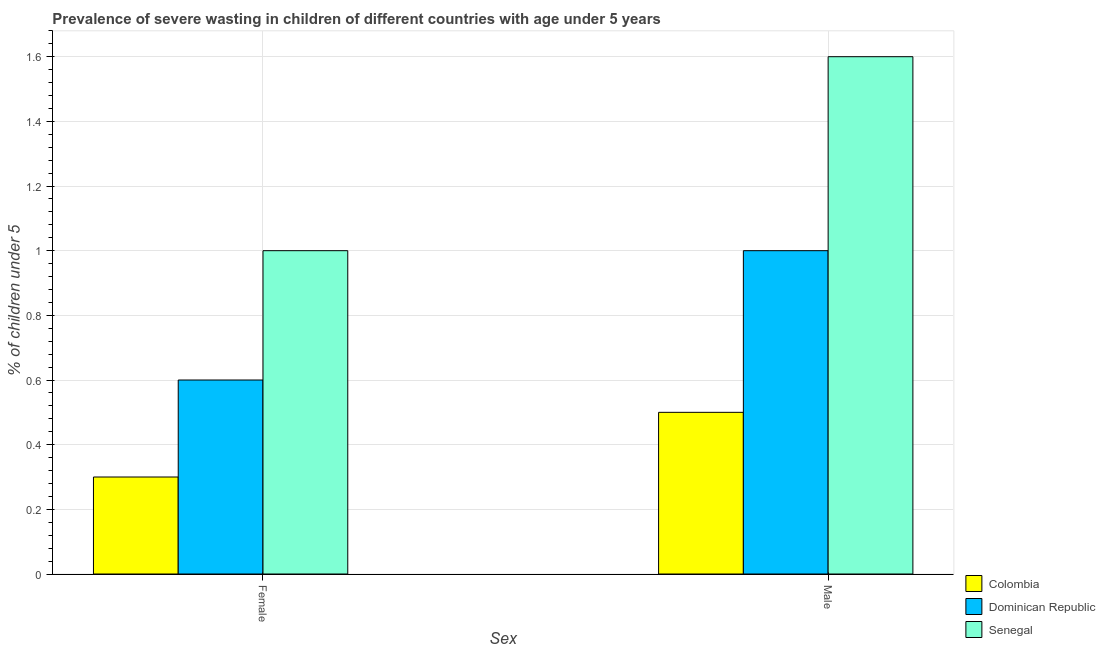How many different coloured bars are there?
Your answer should be compact. 3. Are the number of bars per tick equal to the number of legend labels?
Offer a very short reply. Yes. Are the number of bars on each tick of the X-axis equal?
Offer a terse response. Yes. What is the label of the 2nd group of bars from the left?
Your answer should be compact. Male. Across all countries, what is the maximum percentage of undernourished male children?
Ensure brevity in your answer.  1.6. In which country was the percentage of undernourished female children maximum?
Offer a very short reply. Senegal. What is the total percentage of undernourished female children in the graph?
Make the answer very short. 1.9. What is the difference between the percentage of undernourished female children in Colombia and that in Senegal?
Your answer should be very brief. -0.7. What is the difference between the percentage of undernourished female children in Dominican Republic and the percentage of undernourished male children in Senegal?
Make the answer very short. -1. What is the average percentage of undernourished male children per country?
Your response must be concise. 1.03. What is the difference between the percentage of undernourished male children and percentage of undernourished female children in Dominican Republic?
Offer a terse response. 0.4. In how many countries, is the percentage of undernourished female children greater than 0.44 %?
Ensure brevity in your answer.  2. What is the ratio of the percentage of undernourished female children in Senegal to that in Colombia?
Provide a succinct answer. 3.33. Is the percentage of undernourished male children in Colombia less than that in Dominican Republic?
Ensure brevity in your answer.  Yes. In how many countries, is the percentage of undernourished male children greater than the average percentage of undernourished male children taken over all countries?
Your answer should be compact. 1. What does the 3rd bar from the left in Female represents?
Your answer should be compact. Senegal. What does the 1st bar from the right in Female represents?
Offer a very short reply. Senegal. How many bars are there?
Provide a short and direct response. 6. What is the difference between two consecutive major ticks on the Y-axis?
Provide a short and direct response. 0.2. Does the graph contain any zero values?
Keep it short and to the point. No. Does the graph contain grids?
Provide a succinct answer. Yes. What is the title of the graph?
Provide a succinct answer. Prevalence of severe wasting in children of different countries with age under 5 years. What is the label or title of the X-axis?
Provide a succinct answer. Sex. What is the label or title of the Y-axis?
Keep it short and to the point.  % of children under 5. What is the  % of children under 5 of Colombia in Female?
Keep it short and to the point. 0.3. What is the  % of children under 5 of Dominican Republic in Female?
Make the answer very short. 0.6. What is the  % of children under 5 in Senegal in Female?
Ensure brevity in your answer.  1. What is the  % of children under 5 in Dominican Republic in Male?
Your answer should be compact. 1. What is the  % of children under 5 of Senegal in Male?
Your answer should be very brief. 1.6. Across all Sex, what is the maximum  % of children under 5 of Dominican Republic?
Your answer should be compact. 1. Across all Sex, what is the maximum  % of children under 5 of Senegal?
Make the answer very short. 1.6. Across all Sex, what is the minimum  % of children under 5 of Colombia?
Ensure brevity in your answer.  0.3. Across all Sex, what is the minimum  % of children under 5 of Dominican Republic?
Keep it short and to the point. 0.6. What is the total  % of children under 5 of Colombia in the graph?
Offer a terse response. 0.8. What is the total  % of children under 5 of Dominican Republic in the graph?
Keep it short and to the point. 1.6. What is the total  % of children under 5 of Senegal in the graph?
Your response must be concise. 2.6. What is the difference between the  % of children under 5 of Colombia in Female and that in Male?
Your response must be concise. -0.2. What is the difference between the  % of children under 5 of Colombia in Female and the  % of children under 5 of Senegal in Male?
Make the answer very short. -1.3. What is the difference between the  % of children under 5 in Dominican Republic in Female and the  % of children under 5 in Senegal in Male?
Give a very brief answer. -1. What is the average  % of children under 5 in Colombia per Sex?
Offer a very short reply. 0.4. What is the average  % of children under 5 of Dominican Republic per Sex?
Your response must be concise. 0.8. What is the average  % of children under 5 of Senegal per Sex?
Your answer should be very brief. 1.3. What is the difference between the  % of children under 5 in Colombia and  % of children under 5 in Dominican Republic in Female?
Your answer should be compact. -0.3. What is the difference between the  % of children under 5 in Dominican Republic and  % of children under 5 in Senegal in Female?
Your answer should be compact. -0.4. What is the difference between the  % of children under 5 of Colombia and  % of children under 5 of Dominican Republic in Male?
Your response must be concise. -0.5. What is the difference between the  % of children under 5 of Dominican Republic and  % of children under 5 of Senegal in Male?
Your answer should be compact. -0.6. What is the ratio of the  % of children under 5 in Colombia in Female to that in Male?
Give a very brief answer. 0.6. What is the ratio of the  % of children under 5 of Dominican Republic in Female to that in Male?
Provide a succinct answer. 0.6. What is the ratio of the  % of children under 5 of Senegal in Female to that in Male?
Your answer should be compact. 0.62. What is the difference between the highest and the lowest  % of children under 5 in Colombia?
Ensure brevity in your answer.  0.2. What is the difference between the highest and the lowest  % of children under 5 of Dominican Republic?
Ensure brevity in your answer.  0.4. What is the difference between the highest and the lowest  % of children under 5 in Senegal?
Offer a very short reply. 0.6. 